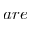<formula> <loc_0><loc_0><loc_500><loc_500>a r e</formula> 